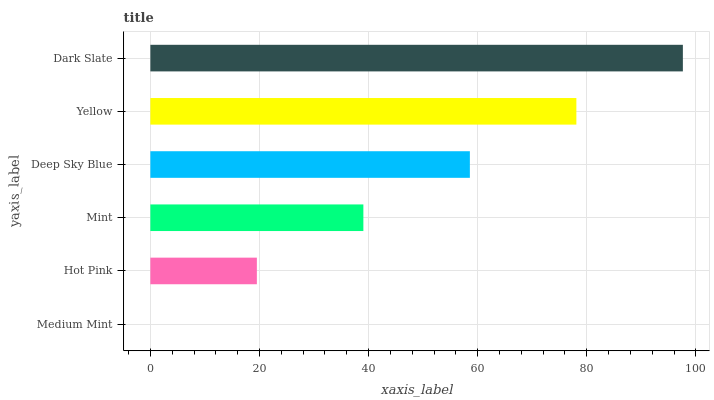Is Medium Mint the minimum?
Answer yes or no. Yes. Is Dark Slate the maximum?
Answer yes or no. Yes. Is Hot Pink the minimum?
Answer yes or no. No. Is Hot Pink the maximum?
Answer yes or no. No. Is Hot Pink greater than Medium Mint?
Answer yes or no. Yes. Is Medium Mint less than Hot Pink?
Answer yes or no. Yes. Is Medium Mint greater than Hot Pink?
Answer yes or no. No. Is Hot Pink less than Medium Mint?
Answer yes or no. No. Is Deep Sky Blue the high median?
Answer yes or no. Yes. Is Mint the low median?
Answer yes or no. Yes. Is Medium Mint the high median?
Answer yes or no. No. Is Deep Sky Blue the low median?
Answer yes or no. No. 